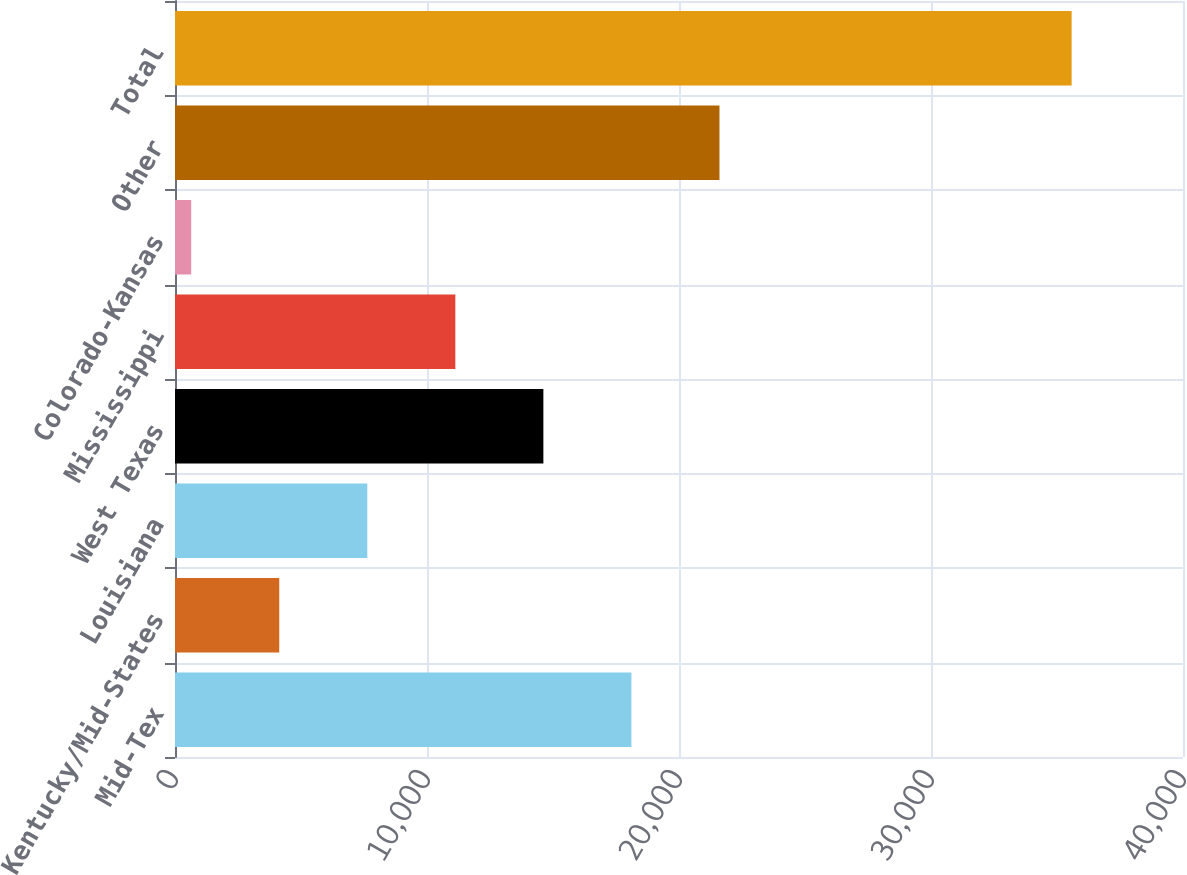Convert chart to OTSL. <chart><loc_0><loc_0><loc_500><loc_500><bar_chart><fcel>Mid-Tex<fcel>Kentucky/Mid-States<fcel>Louisiana<fcel>West Texas<fcel>Mississippi<fcel>Colorado-Kansas<fcel>Other<fcel>Total<nl><fcel>18112<fcel>4136.8<fcel>7630.6<fcel>14618.2<fcel>11124.4<fcel>643<fcel>21605.8<fcel>35581<nl></chart> 